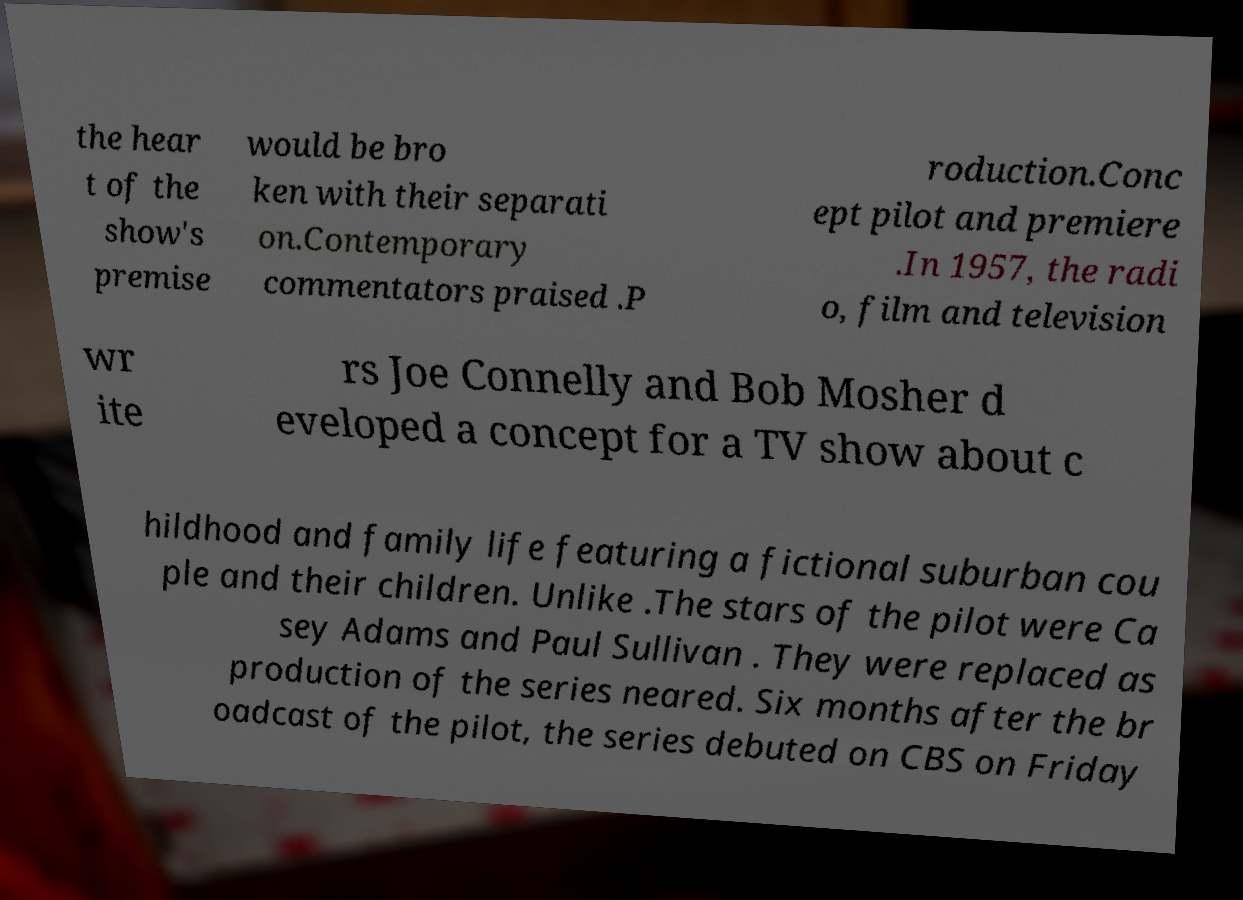For documentation purposes, I need the text within this image transcribed. Could you provide that? the hear t of the show's premise would be bro ken with their separati on.Contemporary commentators praised .P roduction.Conc ept pilot and premiere .In 1957, the radi o, film and television wr ite rs Joe Connelly and Bob Mosher d eveloped a concept for a TV show about c hildhood and family life featuring a fictional suburban cou ple and their children. Unlike .The stars of the pilot were Ca sey Adams and Paul Sullivan . They were replaced as production of the series neared. Six months after the br oadcast of the pilot, the series debuted on CBS on Friday 